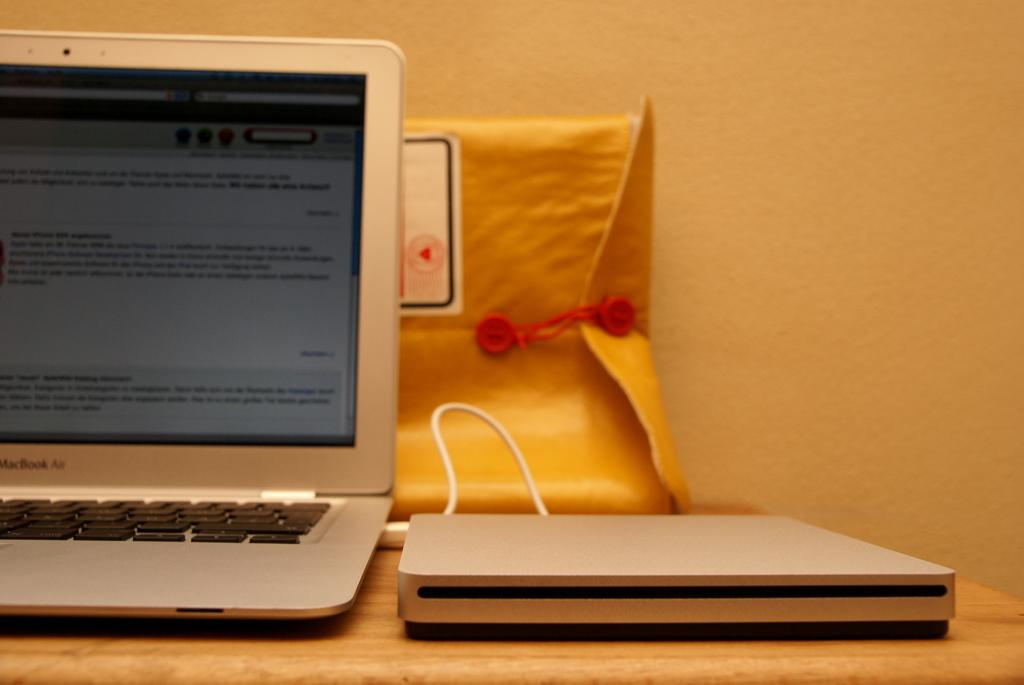What piece of furniture is in the image? There is a table in the image. What electronic device is on the table? A laptop is present on the table. What else can be seen on the table? There is a wire, a hard disk, and a file visible on the table. What is visible in the background of the image? There is a wall in the background of the image. Can you describe the woman's expression as she looks at the apparatus in the image? There is no woman or apparatus present in the image. 